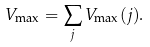Convert formula to latex. <formula><loc_0><loc_0><loc_500><loc_500>V _ { \max } = \sum _ { j } V _ { \max } ( j ) .</formula> 